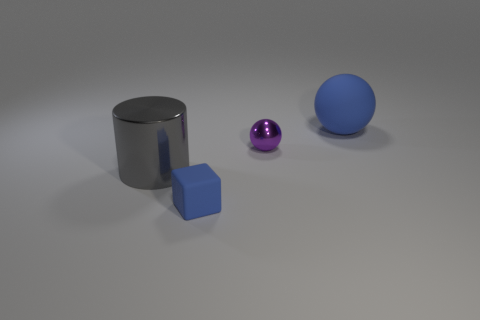Add 1 rubber blocks. How many objects exist? 5 Subtract all blocks. How many objects are left? 3 Add 1 tiny red metallic balls. How many tiny red metallic balls exist? 1 Subtract 0 green blocks. How many objects are left? 4 Subtract all blue cubes. Subtract all big cyan rubber blocks. How many objects are left? 3 Add 1 blue rubber balls. How many blue rubber balls are left? 2 